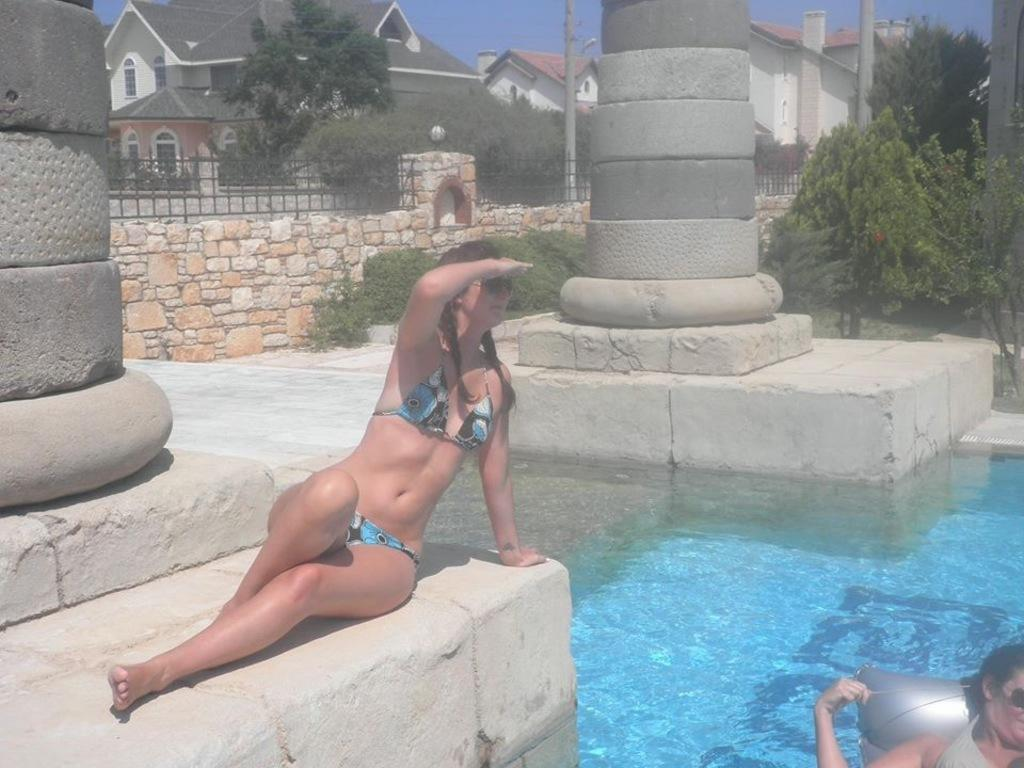How many people are present in the image? There are two people in the image. What is visible in the image besides the people? Water, trees, a wall, poles, buildings with windows, and the sky are visible in the image. Can you describe the buildings in the image? The buildings have windows. What is visible in the background of the image? The sky is visible in the background of the image. What type of orange can be seen in the image? There is no orange present in the image. What pets can be seen accompanying the people in the image? There are no pets visible in the image. 